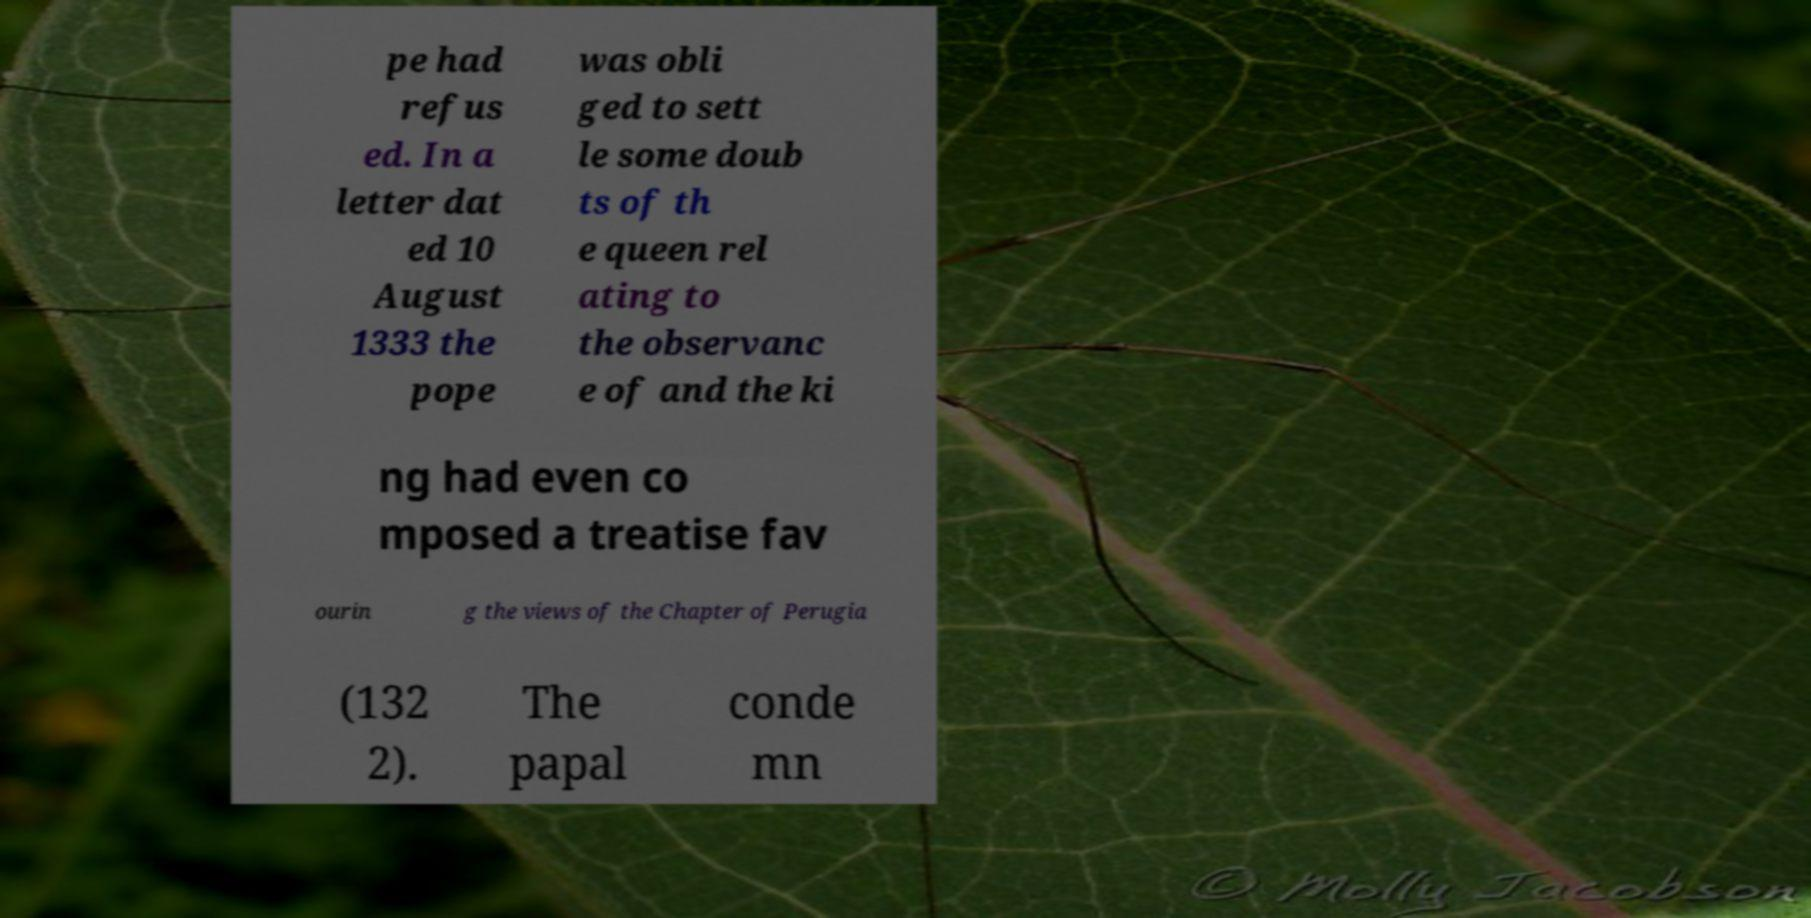Can you read and provide the text displayed in the image?This photo seems to have some interesting text. Can you extract and type it out for me? pe had refus ed. In a letter dat ed 10 August 1333 the pope was obli ged to sett le some doub ts of th e queen rel ating to the observanc e of and the ki ng had even co mposed a treatise fav ourin g the views of the Chapter of Perugia (132 2). The papal conde mn 